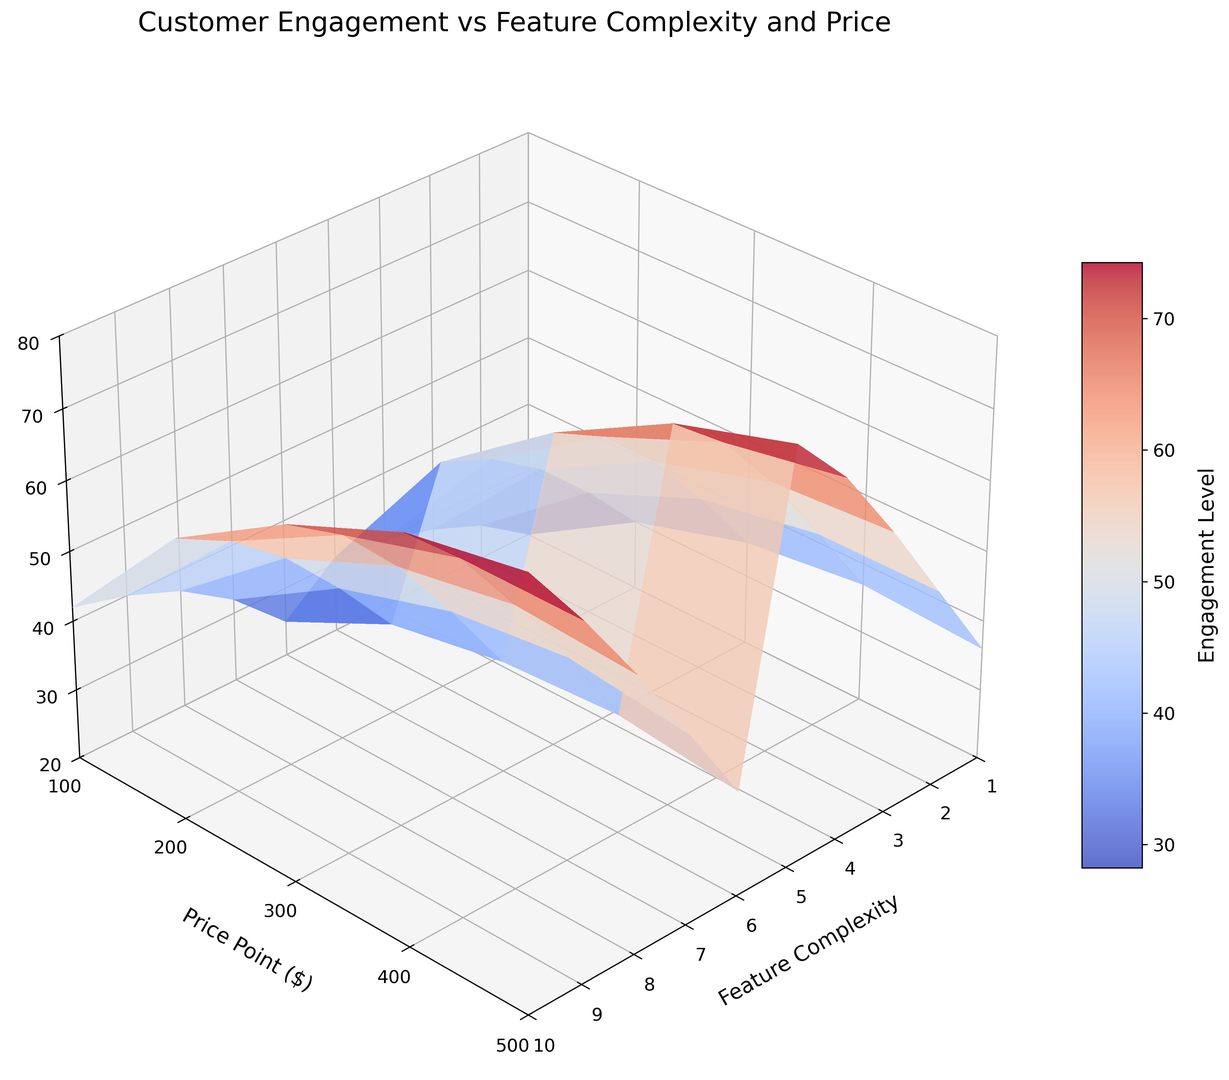What is the engagement level for feature complexity 6 and price point $300? First, locate the point where feature complexity is 6 and price point is $300 on the surface plot. Then, read the corresponding engagement level on the z-axis, which might have a color-coded indicator for reference.
Answer: 57 How does the engagement level change as feature complexity increases from 1 to 10 at a price point of $400? Track the changes in the engagement level on the surface plot along a vertical line corresponding to a price point of $400, from feature complexity 1 to 10.
Answer: It increases from 30 to 70 Which combination of price point and feature complexity results in the highest engagement level? Identify the peak on the 3D surface plot where the z-axis value (engagement level) is the maximum. Observe the corresponding price point and feature complexity at this peak.
Answer: $500 and 10 Is the engagement level more sensitive to changes in feature complexity or price point? Examine the gradients and slopes on the surface plot, noticing whether the surface changes more steeply along the feature complexity axis or the price point axis.
Answer: Feature complexity Compare the engagement levels at the lowest and highest price points for feature complexity 5. Which one is higher? Locate the points on the surface plot where feature complexity is 5, and compare the engagement levels at price points $100 and $500.
Answer: Engagement level at $500 is higher What is the approximate average engagement level for feature complexity 4 across all price points? Locate the points along the feature complexity level of 4, sum their engagement levels, and divide by the number of points (which are price points $100, $200, $300, $400, $500).
Answer: 48.2 How does engagement level change when price point increases from $100 to $500 at feature complexity 3? Track the changes in the engagement level on the surface plot along a horizontal line corresponding to feature complexity 3, from price point $100 to $500.
Answer: It increases from 30 to 53 Is there any price point where engagement is consistent across different feature complexities? Look for horizontal regions on the surface plot where the z-axis value (engagement level) remains constant despite changes in the feature complexity.
Answer: No What is the difference in engagement levels between feature complexity 8 and 1 for price point $300? Locate the points on the plot for price point $300 at feature complexities 8 and 1, and subtract the engagement value of feature complexity 1 from that of feature complexity 8.
Answer: 32 What can we infer about customer preferences based on the visual representation of engagement levels? Examine the overall trends and patterns on the surface plot to identify how customers' engagement levels are influenced by variations in feature complexity and price point, observing regions of peaks and troughs.
Answer: Customers prefer higher feature complexity and moderate to higher price points 